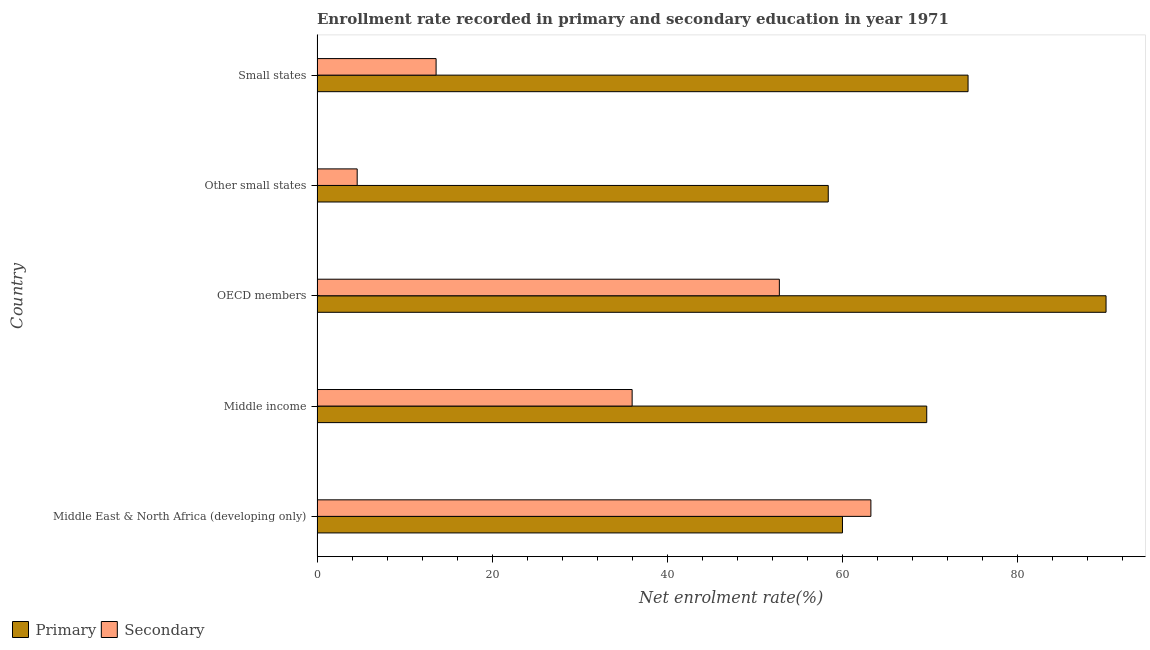Are the number of bars per tick equal to the number of legend labels?
Your answer should be very brief. Yes. How many bars are there on the 5th tick from the bottom?
Make the answer very short. 2. What is the label of the 2nd group of bars from the top?
Make the answer very short. Other small states. What is the enrollment rate in primary education in OECD members?
Keep it short and to the point. 90.09. Across all countries, what is the maximum enrollment rate in primary education?
Keep it short and to the point. 90.09. Across all countries, what is the minimum enrollment rate in primary education?
Ensure brevity in your answer.  58.37. In which country was the enrollment rate in secondary education maximum?
Provide a succinct answer. Middle East & North Africa (developing only). In which country was the enrollment rate in secondary education minimum?
Make the answer very short. Other small states. What is the total enrollment rate in primary education in the graph?
Ensure brevity in your answer.  352.4. What is the difference between the enrollment rate in primary education in Middle East & North Africa (developing only) and that in OECD members?
Offer a very short reply. -30.1. What is the difference between the enrollment rate in primary education in Small states and the enrollment rate in secondary education in OECD members?
Give a very brief answer. 21.55. What is the average enrollment rate in secondary education per country?
Your answer should be compact. 34.04. What is the difference between the enrollment rate in primary education and enrollment rate in secondary education in Other small states?
Offer a very short reply. 53.79. In how many countries, is the enrollment rate in primary education greater than 36 %?
Offer a very short reply. 5. What is the ratio of the enrollment rate in primary education in Middle East & North Africa (developing only) to that in Middle income?
Your answer should be very brief. 0.86. What is the difference between the highest and the second highest enrollment rate in primary education?
Your answer should be very brief. 15.76. What is the difference between the highest and the lowest enrollment rate in primary education?
Ensure brevity in your answer.  31.72. What does the 2nd bar from the top in OECD members represents?
Make the answer very short. Primary. What does the 2nd bar from the bottom in Small states represents?
Offer a very short reply. Secondary. How many bars are there?
Offer a very short reply. 10. How many countries are there in the graph?
Offer a very short reply. 5. What is the difference between two consecutive major ticks on the X-axis?
Your answer should be compact. 20. Are the values on the major ticks of X-axis written in scientific E-notation?
Offer a very short reply. No. Does the graph contain grids?
Your answer should be compact. No. Where does the legend appear in the graph?
Your answer should be compact. Bottom left. How are the legend labels stacked?
Ensure brevity in your answer.  Horizontal. What is the title of the graph?
Your response must be concise. Enrollment rate recorded in primary and secondary education in year 1971. Does "Urban" appear as one of the legend labels in the graph?
Your answer should be compact. No. What is the label or title of the X-axis?
Ensure brevity in your answer.  Net enrolment rate(%). What is the label or title of the Y-axis?
Ensure brevity in your answer.  Country. What is the Net enrolment rate(%) in Primary in Middle East & North Africa (developing only)?
Provide a succinct answer. 59.99. What is the Net enrolment rate(%) in Secondary in Middle East & North Africa (developing only)?
Your response must be concise. 63.24. What is the Net enrolment rate(%) in Primary in Middle income?
Keep it short and to the point. 69.61. What is the Net enrolment rate(%) in Secondary in Middle income?
Provide a succinct answer. 35.98. What is the Net enrolment rate(%) in Primary in OECD members?
Give a very brief answer. 90.09. What is the Net enrolment rate(%) of Secondary in OECD members?
Your response must be concise. 52.79. What is the Net enrolment rate(%) of Primary in Other small states?
Your answer should be very brief. 58.37. What is the Net enrolment rate(%) in Secondary in Other small states?
Offer a terse response. 4.58. What is the Net enrolment rate(%) of Primary in Small states?
Offer a terse response. 74.33. What is the Net enrolment rate(%) in Secondary in Small states?
Ensure brevity in your answer.  13.59. Across all countries, what is the maximum Net enrolment rate(%) of Primary?
Ensure brevity in your answer.  90.09. Across all countries, what is the maximum Net enrolment rate(%) in Secondary?
Give a very brief answer. 63.24. Across all countries, what is the minimum Net enrolment rate(%) in Primary?
Provide a short and direct response. 58.37. Across all countries, what is the minimum Net enrolment rate(%) in Secondary?
Offer a terse response. 4.58. What is the total Net enrolment rate(%) of Primary in the graph?
Your answer should be compact. 352.4. What is the total Net enrolment rate(%) in Secondary in the graph?
Offer a very short reply. 170.18. What is the difference between the Net enrolment rate(%) of Primary in Middle East & North Africa (developing only) and that in Middle income?
Offer a terse response. -9.62. What is the difference between the Net enrolment rate(%) in Secondary in Middle East & North Africa (developing only) and that in Middle income?
Your response must be concise. 27.26. What is the difference between the Net enrolment rate(%) of Primary in Middle East & North Africa (developing only) and that in OECD members?
Your answer should be very brief. -30.1. What is the difference between the Net enrolment rate(%) in Secondary in Middle East & North Africa (developing only) and that in OECD members?
Offer a terse response. 10.45. What is the difference between the Net enrolment rate(%) of Primary in Middle East & North Africa (developing only) and that in Other small states?
Provide a succinct answer. 1.62. What is the difference between the Net enrolment rate(%) in Secondary in Middle East & North Africa (developing only) and that in Other small states?
Ensure brevity in your answer.  58.66. What is the difference between the Net enrolment rate(%) in Primary in Middle East & North Africa (developing only) and that in Small states?
Provide a short and direct response. -14.34. What is the difference between the Net enrolment rate(%) in Secondary in Middle East & North Africa (developing only) and that in Small states?
Your answer should be very brief. 49.65. What is the difference between the Net enrolment rate(%) of Primary in Middle income and that in OECD members?
Make the answer very short. -20.47. What is the difference between the Net enrolment rate(%) in Secondary in Middle income and that in OECD members?
Offer a very short reply. -16.81. What is the difference between the Net enrolment rate(%) of Primary in Middle income and that in Other small states?
Offer a terse response. 11.24. What is the difference between the Net enrolment rate(%) in Secondary in Middle income and that in Other small states?
Your answer should be very brief. 31.39. What is the difference between the Net enrolment rate(%) in Primary in Middle income and that in Small states?
Offer a terse response. -4.72. What is the difference between the Net enrolment rate(%) in Secondary in Middle income and that in Small states?
Your response must be concise. 22.39. What is the difference between the Net enrolment rate(%) of Primary in OECD members and that in Other small states?
Provide a succinct answer. 31.72. What is the difference between the Net enrolment rate(%) in Secondary in OECD members and that in Other small states?
Your answer should be compact. 48.2. What is the difference between the Net enrolment rate(%) of Primary in OECD members and that in Small states?
Give a very brief answer. 15.76. What is the difference between the Net enrolment rate(%) in Secondary in OECD members and that in Small states?
Provide a succinct answer. 39.2. What is the difference between the Net enrolment rate(%) in Primary in Other small states and that in Small states?
Provide a succinct answer. -15.96. What is the difference between the Net enrolment rate(%) of Secondary in Other small states and that in Small states?
Your response must be concise. -9.01. What is the difference between the Net enrolment rate(%) in Primary in Middle East & North Africa (developing only) and the Net enrolment rate(%) in Secondary in Middle income?
Give a very brief answer. 24.02. What is the difference between the Net enrolment rate(%) of Primary in Middle East & North Africa (developing only) and the Net enrolment rate(%) of Secondary in OECD members?
Provide a succinct answer. 7.21. What is the difference between the Net enrolment rate(%) of Primary in Middle East & North Africa (developing only) and the Net enrolment rate(%) of Secondary in Other small states?
Offer a terse response. 55.41. What is the difference between the Net enrolment rate(%) of Primary in Middle East & North Africa (developing only) and the Net enrolment rate(%) of Secondary in Small states?
Offer a very short reply. 46.4. What is the difference between the Net enrolment rate(%) in Primary in Middle income and the Net enrolment rate(%) in Secondary in OECD members?
Ensure brevity in your answer.  16.83. What is the difference between the Net enrolment rate(%) of Primary in Middle income and the Net enrolment rate(%) of Secondary in Other small states?
Offer a terse response. 65.03. What is the difference between the Net enrolment rate(%) in Primary in Middle income and the Net enrolment rate(%) in Secondary in Small states?
Your response must be concise. 56.02. What is the difference between the Net enrolment rate(%) in Primary in OECD members and the Net enrolment rate(%) in Secondary in Other small states?
Make the answer very short. 85.51. What is the difference between the Net enrolment rate(%) in Primary in OECD members and the Net enrolment rate(%) in Secondary in Small states?
Your answer should be compact. 76.5. What is the difference between the Net enrolment rate(%) of Primary in Other small states and the Net enrolment rate(%) of Secondary in Small states?
Provide a short and direct response. 44.78. What is the average Net enrolment rate(%) in Primary per country?
Offer a very short reply. 70.48. What is the average Net enrolment rate(%) of Secondary per country?
Offer a terse response. 34.04. What is the difference between the Net enrolment rate(%) of Primary and Net enrolment rate(%) of Secondary in Middle East & North Africa (developing only)?
Ensure brevity in your answer.  -3.24. What is the difference between the Net enrolment rate(%) of Primary and Net enrolment rate(%) of Secondary in Middle income?
Keep it short and to the point. 33.64. What is the difference between the Net enrolment rate(%) of Primary and Net enrolment rate(%) of Secondary in OECD members?
Make the answer very short. 37.3. What is the difference between the Net enrolment rate(%) of Primary and Net enrolment rate(%) of Secondary in Other small states?
Offer a terse response. 53.79. What is the difference between the Net enrolment rate(%) in Primary and Net enrolment rate(%) in Secondary in Small states?
Make the answer very short. 60.74. What is the ratio of the Net enrolment rate(%) of Primary in Middle East & North Africa (developing only) to that in Middle income?
Provide a succinct answer. 0.86. What is the ratio of the Net enrolment rate(%) of Secondary in Middle East & North Africa (developing only) to that in Middle income?
Give a very brief answer. 1.76. What is the ratio of the Net enrolment rate(%) in Primary in Middle East & North Africa (developing only) to that in OECD members?
Your answer should be compact. 0.67. What is the ratio of the Net enrolment rate(%) of Secondary in Middle East & North Africa (developing only) to that in OECD members?
Your answer should be compact. 1.2. What is the ratio of the Net enrolment rate(%) of Primary in Middle East & North Africa (developing only) to that in Other small states?
Offer a terse response. 1.03. What is the ratio of the Net enrolment rate(%) of Secondary in Middle East & North Africa (developing only) to that in Other small states?
Your answer should be compact. 13.8. What is the ratio of the Net enrolment rate(%) of Primary in Middle East & North Africa (developing only) to that in Small states?
Ensure brevity in your answer.  0.81. What is the ratio of the Net enrolment rate(%) of Secondary in Middle East & North Africa (developing only) to that in Small states?
Provide a succinct answer. 4.65. What is the ratio of the Net enrolment rate(%) of Primary in Middle income to that in OECD members?
Give a very brief answer. 0.77. What is the ratio of the Net enrolment rate(%) of Secondary in Middle income to that in OECD members?
Offer a very short reply. 0.68. What is the ratio of the Net enrolment rate(%) of Primary in Middle income to that in Other small states?
Your answer should be very brief. 1.19. What is the ratio of the Net enrolment rate(%) of Secondary in Middle income to that in Other small states?
Make the answer very short. 7.85. What is the ratio of the Net enrolment rate(%) in Primary in Middle income to that in Small states?
Provide a short and direct response. 0.94. What is the ratio of the Net enrolment rate(%) in Secondary in Middle income to that in Small states?
Offer a very short reply. 2.65. What is the ratio of the Net enrolment rate(%) in Primary in OECD members to that in Other small states?
Make the answer very short. 1.54. What is the ratio of the Net enrolment rate(%) of Secondary in OECD members to that in Other small states?
Offer a terse response. 11.52. What is the ratio of the Net enrolment rate(%) of Primary in OECD members to that in Small states?
Keep it short and to the point. 1.21. What is the ratio of the Net enrolment rate(%) of Secondary in OECD members to that in Small states?
Your response must be concise. 3.88. What is the ratio of the Net enrolment rate(%) of Primary in Other small states to that in Small states?
Your response must be concise. 0.79. What is the ratio of the Net enrolment rate(%) of Secondary in Other small states to that in Small states?
Your answer should be compact. 0.34. What is the difference between the highest and the second highest Net enrolment rate(%) in Primary?
Make the answer very short. 15.76. What is the difference between the highest and the second highest Net enrolment rate(%) in Secondary?
Keep it short and to the point. 10.45. What is the difference between the highest and the lowest Net enrolment rate(%) of Primary?
Make the answer very short. 31.72. What is the difference between the highest and the lowest Net enrolment rate(%) of Secondary?
Offer a terse response. 58.66. 